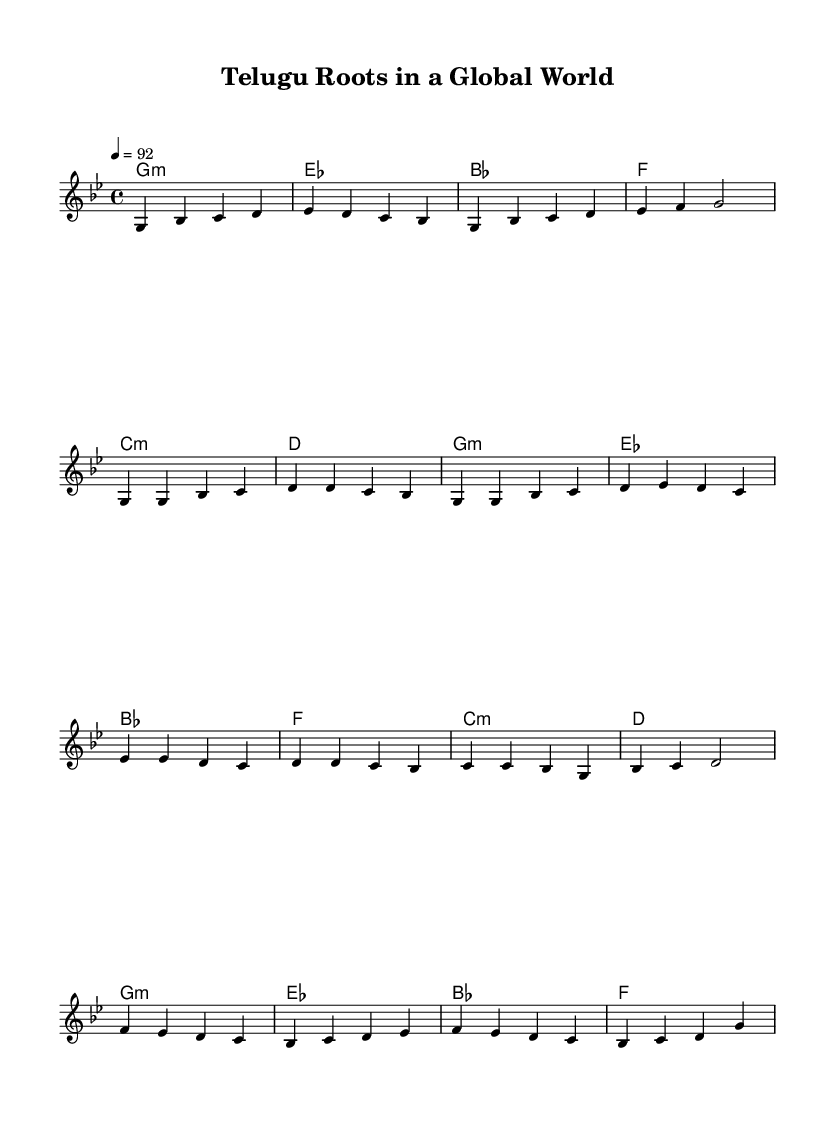What is the key signature of this music? The key signature is indicated at the beginning of the staff. It shows a B-flat and an E-flat, which defines the scale. Thus, the key signature is G minor.
Answer: G minor What is the time signature of this music? The time signature is displayed at the beginning of the staff, indicating the number of beats in a measure and the note value of those beats. Here, it shows 4/4, which means there are four beats per measure with a quarter note receiving one beat.
Answer: 4/4 What is the tempo marking for this piece? The tempo is indicated at the beginning of the score. It states ‘4 = 92’, which signifies that a quarter note is played at a speed of 92 beats per minute.
Answer: 92 How many sections are there in the melody? The melody has distinct parts including an intro, verse, chorus, and bridge as defined by the structure in the sheet music. There are four labeled sections indicating its organization.
Answer: Four What chord follows the E-flat major chord in the harmonies? The harmonies indicate a sequence of chords. After the E-flat major chord (the third chord in the repeat), the next chord listed in the sequence is a B-flat major chord.
Answer: B-flat Which section is indicated as the chorus? In the melody section, the repeatable lyrics or phrases are often referred to as the chorus, which is labeled clearly in the score. In this case, it is the section labeled as "Chorus" after the verse.
Answer: Chorus 